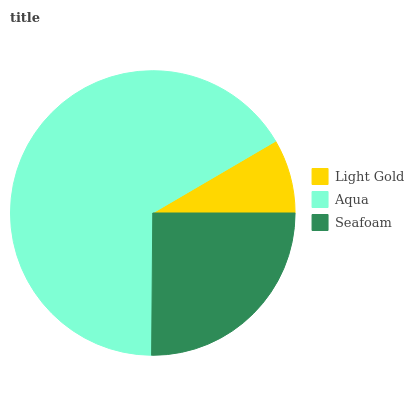Is Light Gold the minimum?
Answer yes or no. Yes. Is Aqua the maximum?
Answer yes or no. Yes. Is Seafoam the minimum?
Answer yes or no. No. Is Seafoam the maximum?
Answer yes or no. No. Is Aqua greater than Seafoam?
Answer yes or no. Yes. Is Seafoam less than Aqua?
Answer yes or no. Yes. Is Seafoam greater than Aqua?
Answer yes or no. No. Is Aqua less than Seafoam?
Answer yes or no. No. Is Seafoam the high median?
Answer yes or no. Yes. Is Seafoam the low median?
Answer yes or no. Yes. Is Light Gold the high median?
Answer yes or no. No. Is Aqua the low median?
Answer yes or no. No. 